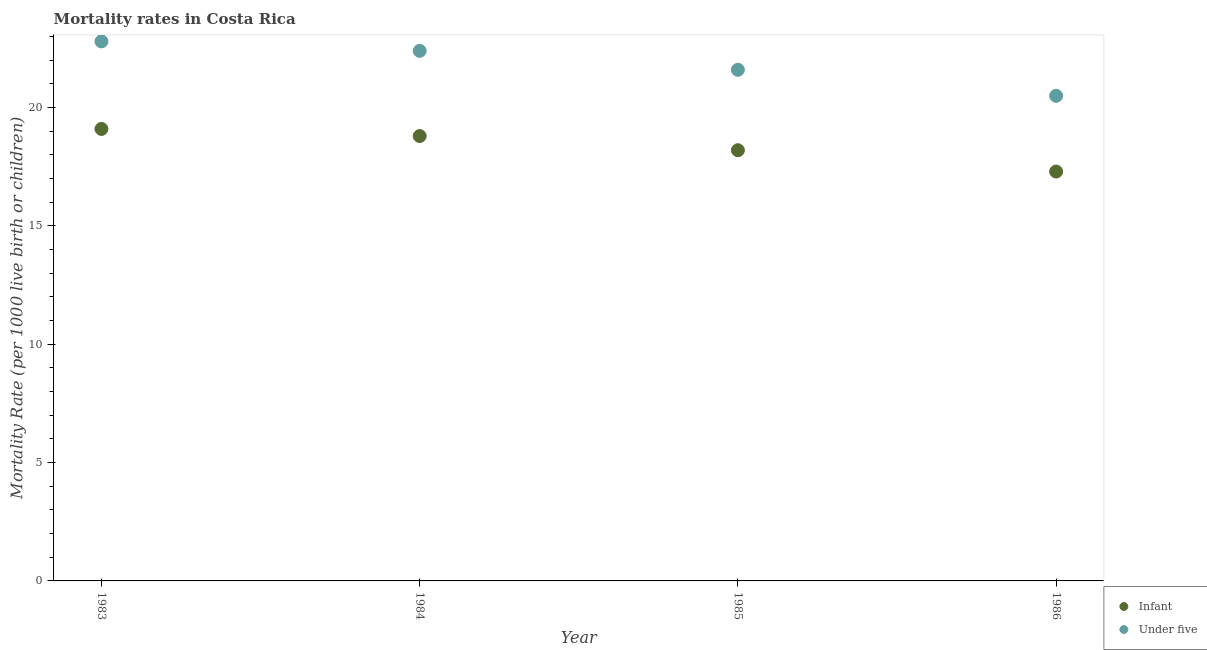How many different coloured dotlines are there?
Your answer should be very brief. 2. What is the under-5 mortality rate in 1983?
Your answer should be compact. 22.8. In which year was the under-5 mortality rate maximum?
Give a very brief answer. 1983. In which year was the infant mortality rate minimum?
Make the answer very short. 1986. What is the total infant mortality rate in the graph?
Your response must be concise. 73.4. What is the difference between the under-5 mortality rate in 1983 and that in 1984?
Provide a short and direct response. 0.4. What is the difference between the under-5 mortality rate in 1986 and the infant mortality rate in 1984?
Your answer should be very brief. 1.7. What is the average infant mortality rate per year?
Ensure brevity in your answer.  18.35. In the year 1986, what is the difference between the infant mortality rate and under-5 mortality rate?
Offer a very short reply. -3.2. What is the ratio of the infant mortality rate in 1983 to that in 1985?
Provide a succinct answer. 1.05. What is the difference between the highest and the second highest under-5 mortality rate?
Provide a succinct answer. 0.4. What is the difference between the highest and the lowest under-5 mortality rate?
Provide a succinct answer. 2.3. Is the sum of the infant mortality rate in 1984 and 1985 greater than the maximum under-5 mortality rate across all years?
Make the answer very short. Yes. Does the under-5 mortality rate monotonically increase over the years?
Your response must be concise. No. Is the under-5 mortality rate strictly less than the infant mortality rate over the years?
Make the answer very short. No. Are the values on the major ticks of Y-axis written in scientific E-notation?
Keep it short and to the point. No. How are the legend labels stacked?
Your answer should be very brief. Vertical. What is the title of the graph?
Make the answer very short. Mortality rates in Costa Rica. What is the label or title of the X-axis?
Ensure brevity in your answer.  Year. What is the label or title of the Y-axis?
Provide a short and direct response. Mortality Rate (per 1000 live birth or children). What is the Mortality Rate (per 1000 live birth or children) of Under five in 1983?
Offer a terse response. 22.8. What is the Mortality Rate (per 1000 live birth or children) of Infant in 1984?
Your answer should be very brief. 18.8. What is the Mortality Rate (per 1000 live birth or children) in Under five in 1984?
Provide a succinct answer. 22.4. What is the Mortality Rate (per 1000 live birth or children) of Under five in 1985?
Provide a short and direct response. 21.6. Across all years, what is the maximum Mortality Rate (per 1000 live birth or children) in Under five?
Keep it short and to the point. 22.8. Across all years, what is the minimum Mortality Rate (per 1000 live birth or children) in Infant?
Your answer should be very brief. 17.3. Across all years, what is the minimum Mortality Rate (per 1000 live birth or children) of Under five?
Offer a terse response. 20.5. What is the total Mortality Rate (per 1000 live birth or children) in Infant in the graph?
Provide a short and direct response. 73.4. What is the total Mortality Rate (per 1000 live birth or children) in Under five in the graph?
Make the answer very short. 87.3. What is the difference between the Mortality Rate (per 1000 live birth or children) in Infant in 1983 and that in 1984?
Offer a very short reply. 0.3. What is the difference between the Mortality Rate (per 1000 live birth or children) in Under five in 1983 and that in 1984?
Your answer should be very brief. 0.4. What is the difference between the Mortality Rate (per 1000 live birth or children) of Infant in 1983 and that in 1985?
Provide a short and direct response. 0.9. What is the difference between the Mortality Rate (per 1000 live birth or children) of Under five in 1983 and that in 1985?
Provide a succinct answer. 1.2. What is the difference between the Mortality Rate (per 1000 live birth or children) in Infant in 1983 and that in 1986?
Your answer should be very brief. 1.8. What is the difference between the Mortality Rate (per 1000 live birth or children) in Under five in 1983 and that in 1986?
Make the answer very short. 2.3. What is the difference between the Mortality Rate (per 1000 live birth or children) in Infant in 1984 and that in 1985?
Provide a succinct answer. 0.6. What is the difference between the Mortality Rate (per 1000 live birth or children) in Infant in 1984 and that in 1986?
Provide a succinct answer. 1.5. What is the difference between the Mortality Rate (per 1000 live birth or children) in Under five in 1984 and that in 1986?
Keep it short and to the point. 1.9. What is the difference between the Mortality Rate (per 1000 live birth or children) in Infant in 1985 and that in 1986?
Your response must be concise. 0.9. What is the difference between the Mortality Rate (per 1000 live birth or children) of Under five in 1985 and that in 1986?
Keep it short and to the point. 1.1. What is the difference between the Mortality Rate (per 1000 live birth or children) of Infant in 1983 and the Mortality Rate (per 1000 live birth or children) of Under five in 1984?
Ensure brevity in your answer.  -3.3. What is the difference between the Mortality Rate (per 1000 live birth or children) of Infant in 1983 and the Mortality Rate (per 1000 live birth or children) of Under five in 1985?
Ensure brevity in your answer.  -2.5. What is the difference between the Mortality Rate (per 1000 live birth or children) of Infant in 1983 and the Mortality Rate (per 1000 live birth or children) of Under five in 1986?
Your response must be concise. -1.4. What is the difference between the Mortality Rate (per 1000 live birth or children) in Infant in 1984 and the Mortality Rate (per 1000 live birth or children) in Under five in 1985?
Make the answer very short. -2.8. What is the difference between the Mortality Rate (per 1000 live birth or children) in Infant in 1984 and the Mortality Rate (per 1000 live birth or children) in Under five in 1986?
Provide a succinct answer. -1.7. What is the difference between the Mortality Rate (per 1000 live birth or children) of Infant in 1985 and the Mortality Rate (per 1000 live birth or children) of Under five in 1986?
Your answer should be very brief. -2.3. What is the average Mortality Rate (per 1000 live birth or children) of Infant per year?
Your answer should be very brief. 18.35. What is the average Mortality Rate (per 1000 live birth or children) in Under five per year?
Give a very brief answer. 21.82. In the year 1983, what is the difference between the Mortality Rate (per 1000 live birth or children) in Infant and Mortality Rate (per 1000 live birth or children) in Under five?
Your response must be concise. -3.7. In the year 1984, what is the difference between the Mortality Rate (per 1000 live birth or children) in Infant and Mortality Rate (per 1000 live birth or children) in Under five?
Make the answer very short. -3.6. In the year 1985, what is the difference between the Mortality Rate (per 1000 live birth or children) in Infant and Mortality Rate (per 1000 live birth or children) in Under five?
Provide a succinct answer. -3.4. What is the ratio of the Mortality Rate (per 1000 live birth or children) in Infant in 1983 to that in 1984?
Keep it short and to the point. 1.02. What is the ratio of the Mortality Rate (per 1000 live birth or children) in Under five in 1983 to that in 1984?
Your response must be concise. 1.02. What is the ratio of the Mortality Rate (per 1000 live birth or children) of Infant in 1983 to that in 1985?
Make the answer very short. 1.05. What is the ratio of the Mortality Rate (per 1000 live birth or children) in Under five in 1983 to that in 1985?
Ensure brevity in your answer.  1.06. What is the ratio of the Mortality Rate (per 1000 live birth or children) of Infant in 1983 to that in 1986?
Make the answer very short. 1.1. What is the ratio of the Mortality Rate (per 1000 live birth or children) in Under five in 1983 to that in 1986?
Your answer should be very brief. 1.11. What is the ratio of the Mortality Rate (per 1000 live birth or children) of Infant in 1984 to that in 1985?
Provide a succinct answer. 1.03. What is the ratio of the Mortality Rate (per 1000 live birth or children) in Infant in 1984 to that in 1986?
Keep it short and to the point. 1.09. What is the ratio of the Mortality Rate (per 1000 live birth or children) in Under five in 1984 to that in 1986?
Provide a short and direct response. 1.09. What is the ratio of the Mortality Rate (per 1000 live birth or children) of Infant in 1985 to that in 1986?
Provide a short and direct response. 1.05. What is the ratio of the Mortality Rate (per 1000 live birth or children) in Under five in 1985 to that in 1986?
Provide a succinct answer. 1.05. What is the difference between the highest and the second highest Mortality Rate (per 1000 live birth or children) in Infant?
Offer a terse response. 0.3. What is the difference between the highest and the second highest Mortality Rate (per 1000 live birth or children) of Under five?
Your answer should be compact. 0.4. What is the difference between the highest and the lowest Mortality Rate (per 1000 live birth or children) of Infant?
Give a very brief answer. 1.8. What is the difference between the highest and the lowest Mortality Rate (per 1000 live birth or children) in Under five?
Keep it short and to the point. 2.3. 